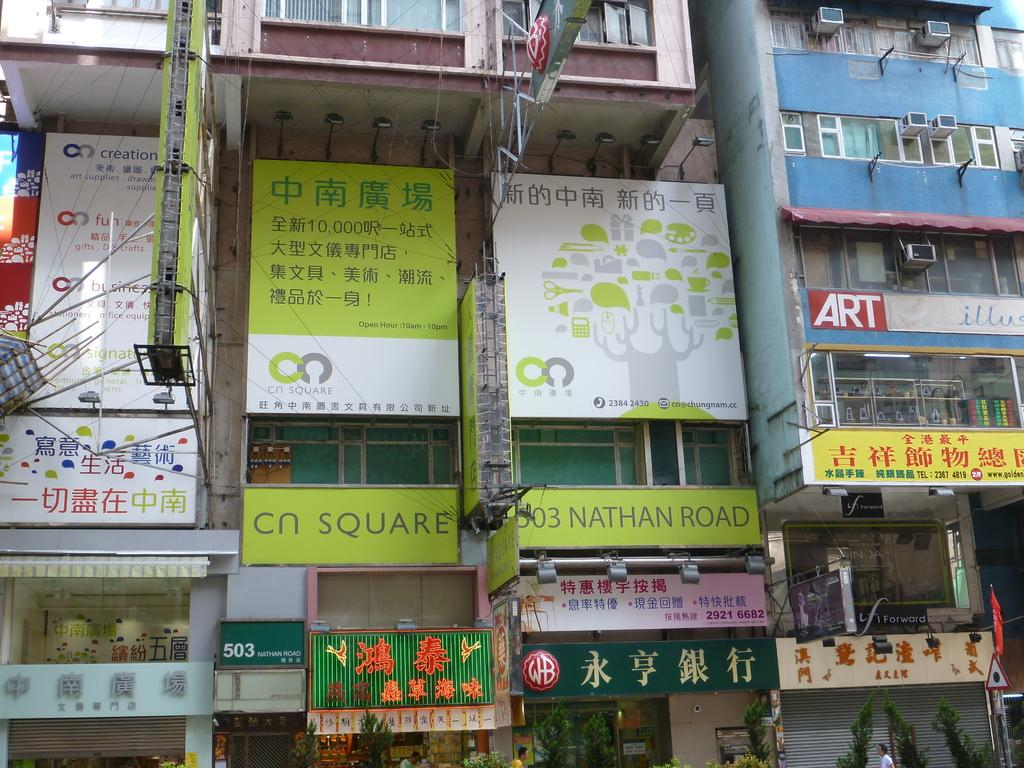<image>
Describe the image concisely. A bunch of stores closely stacked together, the center one being Cn Square. 